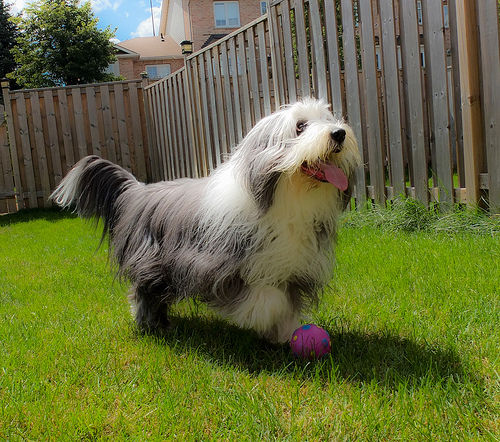<image>
Is there a fur on the grass? Yes. Looking at the image, I can see the fur is positioned on top of the grass, with the grass providing support. Is the dog on the grass? Yes. Looking at the image, I can see the dog is positioned on top of the grass, with the grass providing support. Is there a fence above the dog? No. The fence is not positioned above the dog. The vertical arrangement shows a different relationship. 